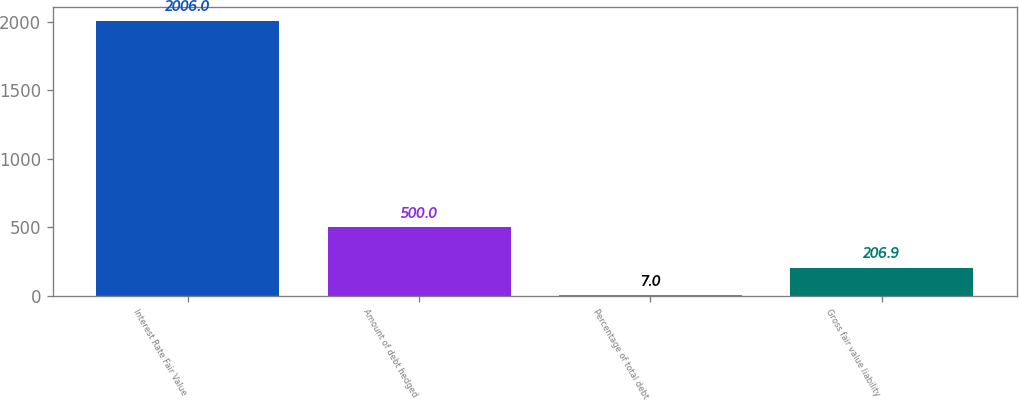Convert chart. <chart><loc_0><loc_0><loc_500><loc_500><bar_chart><fcel>Interest Rate Fair Value<fcel>Amount of debt hedged<fcel>Percentage of total debt<fcel>Gross fair value liability<nl><fcel>2006<fcel>500<fcel>7<fcel>206.9<nl></chart> 